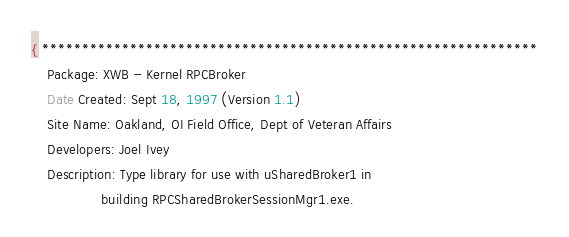Convert code to text. <code><loc_0><loc_0><loc_500><loc_500><_Pascal_>{ **************************************************************
	Package: XWB - Kernel RPCBroker
	Date Created: Sept 18, 1997 (Version 1.1)
	Site Name: Oakland, OI Field Office, Dept of Veteran Affairs
	Developers: Joel Ivey
	Description: Type library for use with uSharedBroker1 in
	             building RPCSharedBrokerSessionMgr1.exe.</code> 